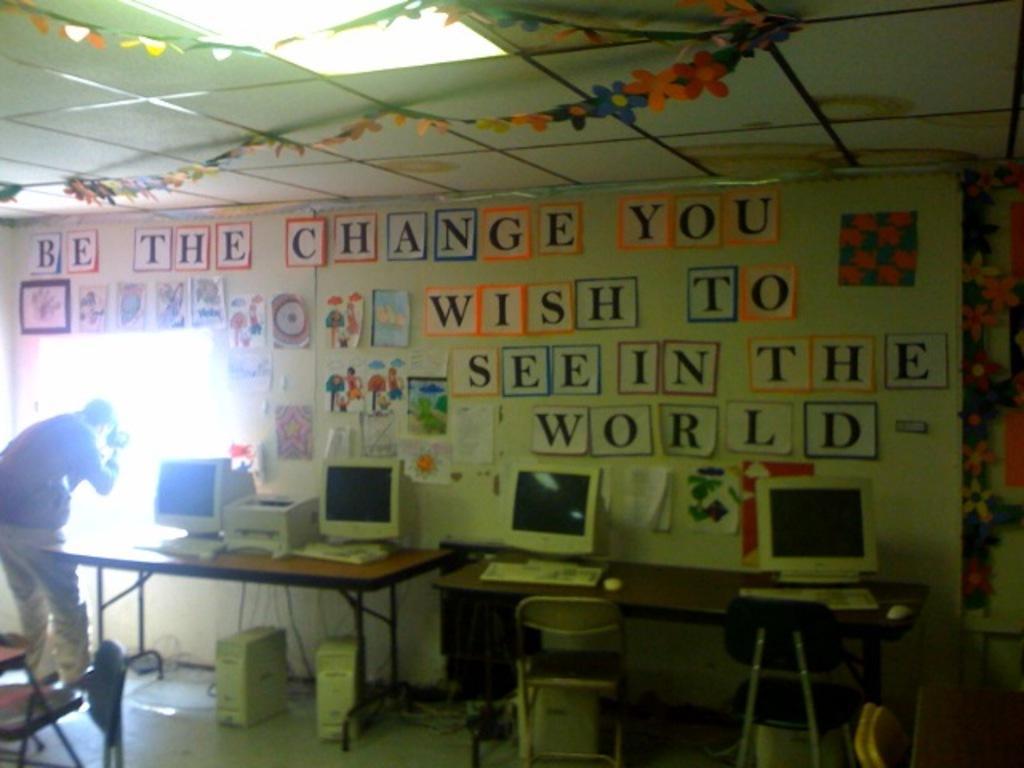Please provide a concise description of this image. There are so many stickers pasted on wall and computers on table and man looking outside. 